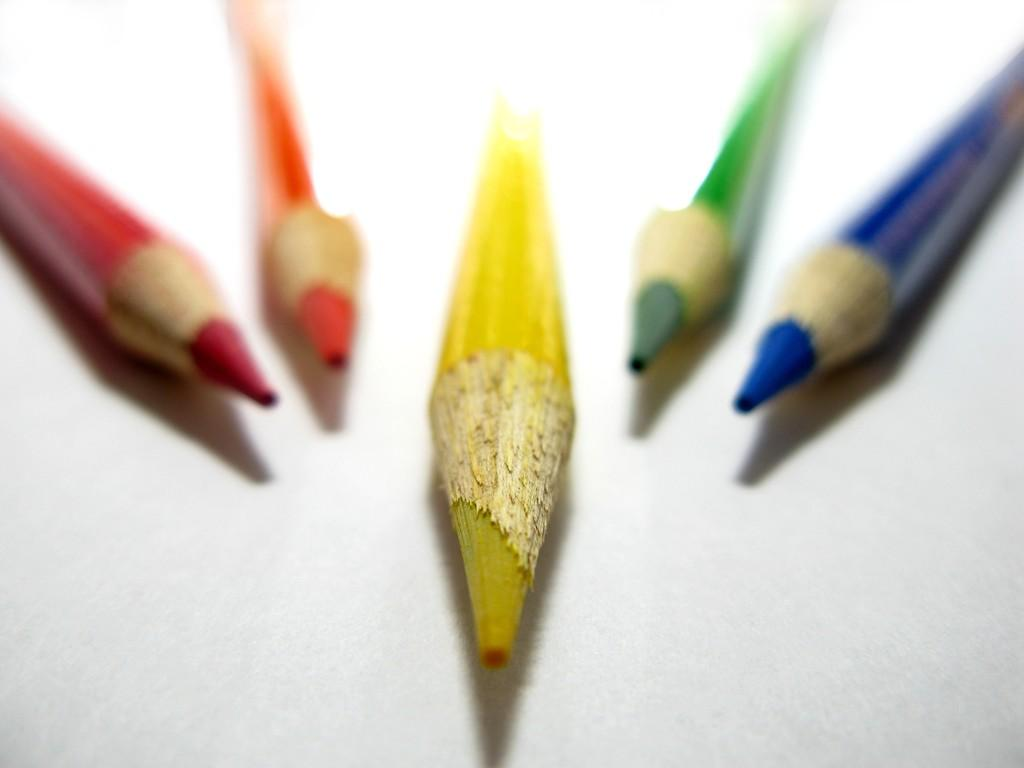What objects are present in the image? There are color pencils in the image. What is the color pencils placed on? The color pencils are on a white surface. Can you see any feathers in the image? No, there are no feathers present in the image. What is the cause of the color pencils being on the white surface? The provided facts do not give any information about the cause of the color pencils being on the white surface. 